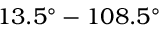Convert formula to latex. <formula><loc_0><loc_0><loc_500><loc_500>1 3 . 5 ^ { \circ } - 1 0 8 . 5 ^ { \circ }</formula> 